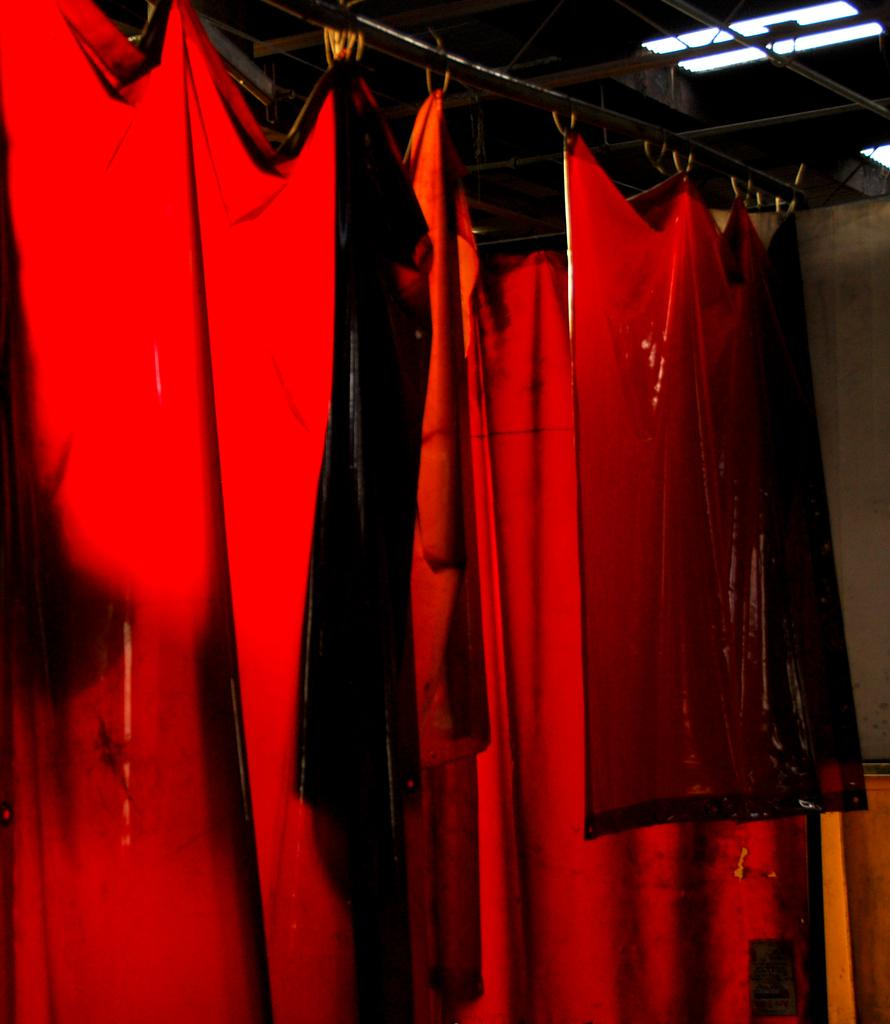What type of window treatment is visible in the image? There are curtains in the image. Where are the lights located in the image? The lights are in the top right of the image. How does the fan affect the curtains in the image? There is no fan present in the image, so it cannot affect the curtains. 